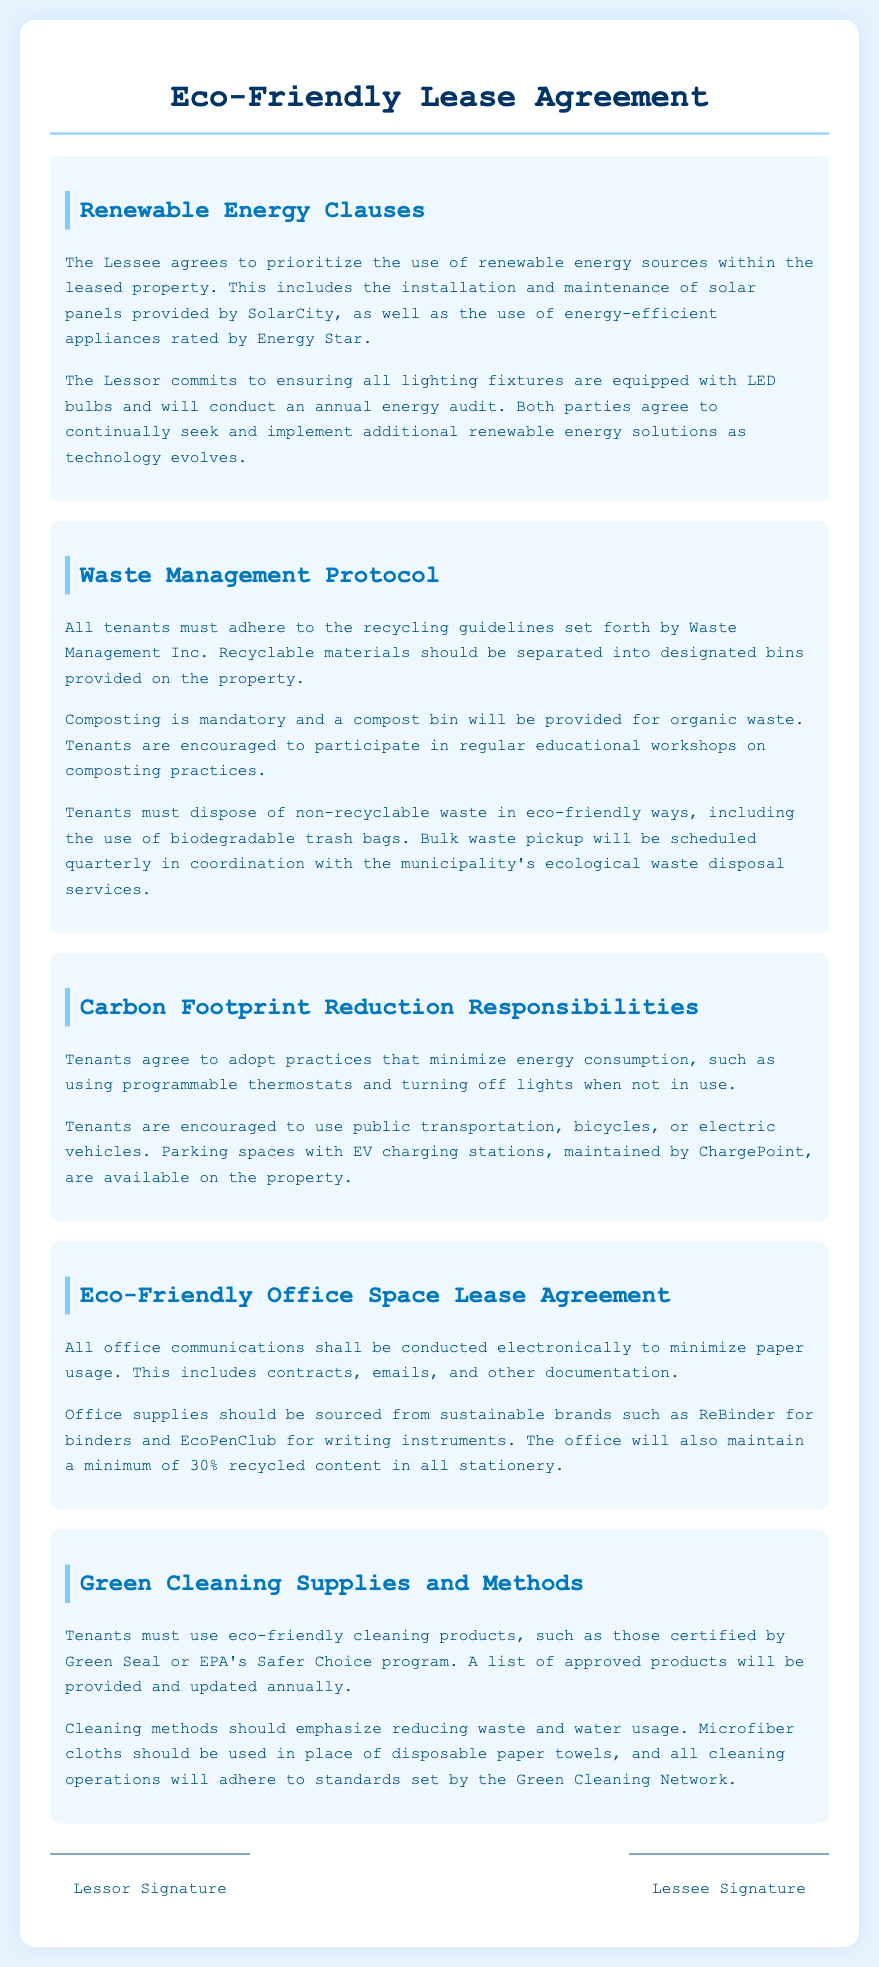What is the purpose of the eco-friendly lease agreement? The purpose of the eco-friendly lease agreement is to outline the terms and responsibilities of using renewable energy and sustainable practices within the leased property.
Answer: Eco-Friendly Lease Agreement What is required for waste disposal? Tenants must adhere to recycling guidelines, participate in composting, and use biodegradable trash bags for non-recyclable waste.
Answer: Recycling, composting, biodegradable trash bags Who provides the solar panels? The solar panels are provided by SolarCity.
Answer: SolarCity What type of office supplies should be sourced? Office supplies should be sourced from sustainable brands such as ReBinder and EcoPenClub.
Answer: Sustainable brands How often will bulk waste pickup be scheduled? Bulk waste pickup will be scheduled quarterly.
Answer: Quarterly What type of transportation is encouraged? Tenants are encouraged to use public transportation, bicycles, or electric vehicles.
Answer: Public transportation, bicycles, electric vehicles What cleaning products should tenants use? Tenants must use eco-friendly cleaning products certified by Green Seal or EPA's Safer Choice program.
Answer: Eco-friendly cleaning products What must tenants do to reduce their carbon footprint? Tenants agree to adopt practices such as using programmable thermostats and turning off lights when not in use.
Answer: Use programmable thermostats, turn off lights What is the minimum recycled content required in stationery? The office will maintain a minimum of 30% recycled content in all stationery.
Answer: 30% 